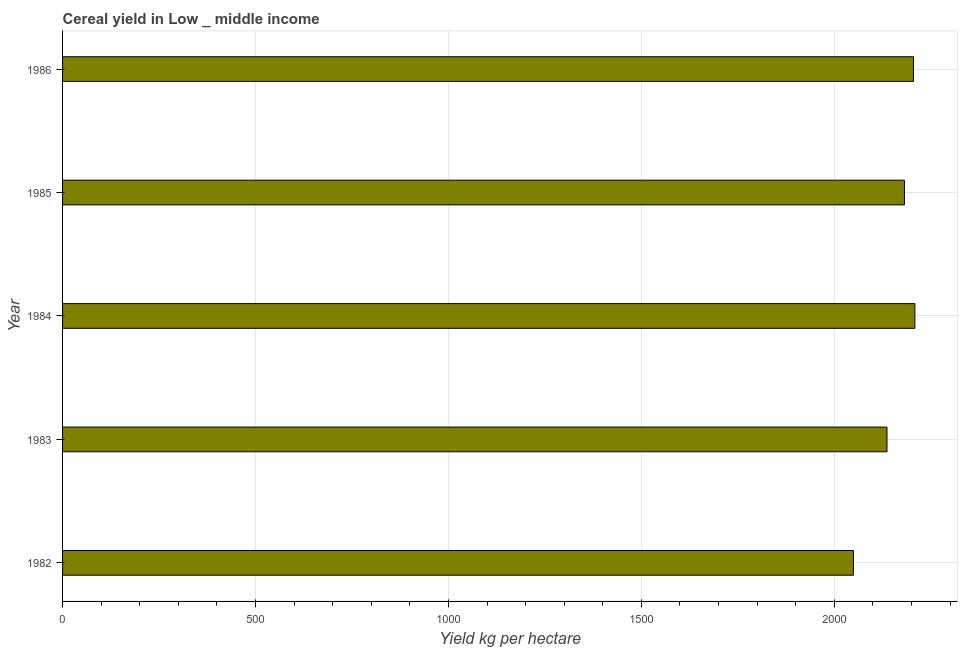Does the graph contain any zero values?
Offer a very short reply. No. What is the title of the graph?
Your answer should be very brief. Cereal yield in Low _ middle income. What is the label or title of the X-axis?
Your answer should be compact. Yield kg per hectare. What is the cereal yield in 1986?
Your answer should be compact. 2205.29. Across all years, what is the maximum cereal yield?
Ensure brevity in your answer.  2208.86. Across all years, what is the minimum cereal yield?
Your answer should be compact. 2049.6. What is the sum of the cereal yield?
Offer a terse response. 1.08e+04. What is the difference between the cereal yield in 1983 and 1985?
Your answer should be very brief. -45.25. What is the average cereal yield per year?
Your response must be concise. 2156.43. What is the median cereal yield?
Offer a terse response. 2181.83. In how many years, is the cereal yield greater than 1100 kg per hectare?
Make the answer very short. 5. Do a majority of the years between 1986 and 1983 (inclusive) have cereal yield greater than 1800 kg per hectare?
Offer a terse response. Yes. What is the ratio of the cereal yield in 1982 to that in 1984?
Offer a terse response. 0.93. Is the cereal yield in 1984 less than that in 1985?
Your answer should be very brief. No. Is the difference between the cereal yield in 1983 and 1986 greater than the difference between any two years?
Your answer should be very brief. No. What is the difference between the highest and the second highest cereal yield?
Offer a terse response. 3.57. What is the difference between the highest and the lowest cereal yield?
Give a very brief answer. 159.26. In how many years, is the cereal yield greater than the average cereal yield taken over all years?
Ensure brevity in your answer.  3. What is the difference between two consecutive major ticks on the X-axis?
Your answer should be very brief. 500. Are the values on the major ticks of X-axis written in scientific E-notation?
Ensure brevity in your answer.  No. What is the Yield kg per hectare in 1982?
Your answer should be compact. 2049.6. What is the Yield kg per hectare of 1983?
Your response must be concise. 2136.58. What is the Yield kg per hectare in 1984?
Provide a succinct answer. 2208.86. What is the Yield kg per hectare of 1985?
Offer a very short reply. 2181.83. What is the Yield kg per hectare in 1986?
Your answer should be very brief. 2205.29. What is the difference between the Yield kg per hectare in 1982 and 1983?
Your answer should be very brief. -86.99. What is the difference between the Yield kg per hectare in 1982 and 1984?
Offer a terse response. -159.26. What is the difference between the Yield kg per hectare in 1982 and 1985?
Provide a succinct answer. -132.24. What is the difference between the Yield kg per hectare in 1982 and 1986?
Ensure brevity in your answer.  -155.69. What is the difference between the Yield kg per hectare in 1983 and 1984?
Provide a short and direct response. -72.27. What is the difference between the Yield kg per hectare in 1983 and 1985?
Keep it short and to the point. -45.25. What is the difference between the Yield kg per hectare in 1983 and 1986?
Provide a short and direct response. -68.7. What is the difference between the Yield kg per hectare in 1984 and 1985?
Offer a terse response. 27.02. What is the difference between the Yield kg per hectare in 1984 and 1986?
Make the answer very short. 3.57. What is the difference between the Yield kg per hectare in 1985 and 1986?
Your response must be concise. -23.45. What is the ratio of the Yield kg per hectare in 1982 to that in 1984?
Provide a short and direct response. 0.93. What is the ratio of the Yield kg per hectare in 1982 to that in 1985?
Your answer should be very brief. 0.94. What is the ratio of the Yield kg per hectare in 1982 to that in 1986?
Make the answer very short. 0.93. What is the ratio of the Yield kg per hectare in 1983 to that in 1985?
Keep it short and to the point. 0.98. What is the ratio of the Yield kg per hectare in 1983 to that in 1986?
Offer a terse response. 0.97. What is the ratio of the Yield kg per hectare in 1984 to that in 1986?
Your answer should be very brief. 1. 